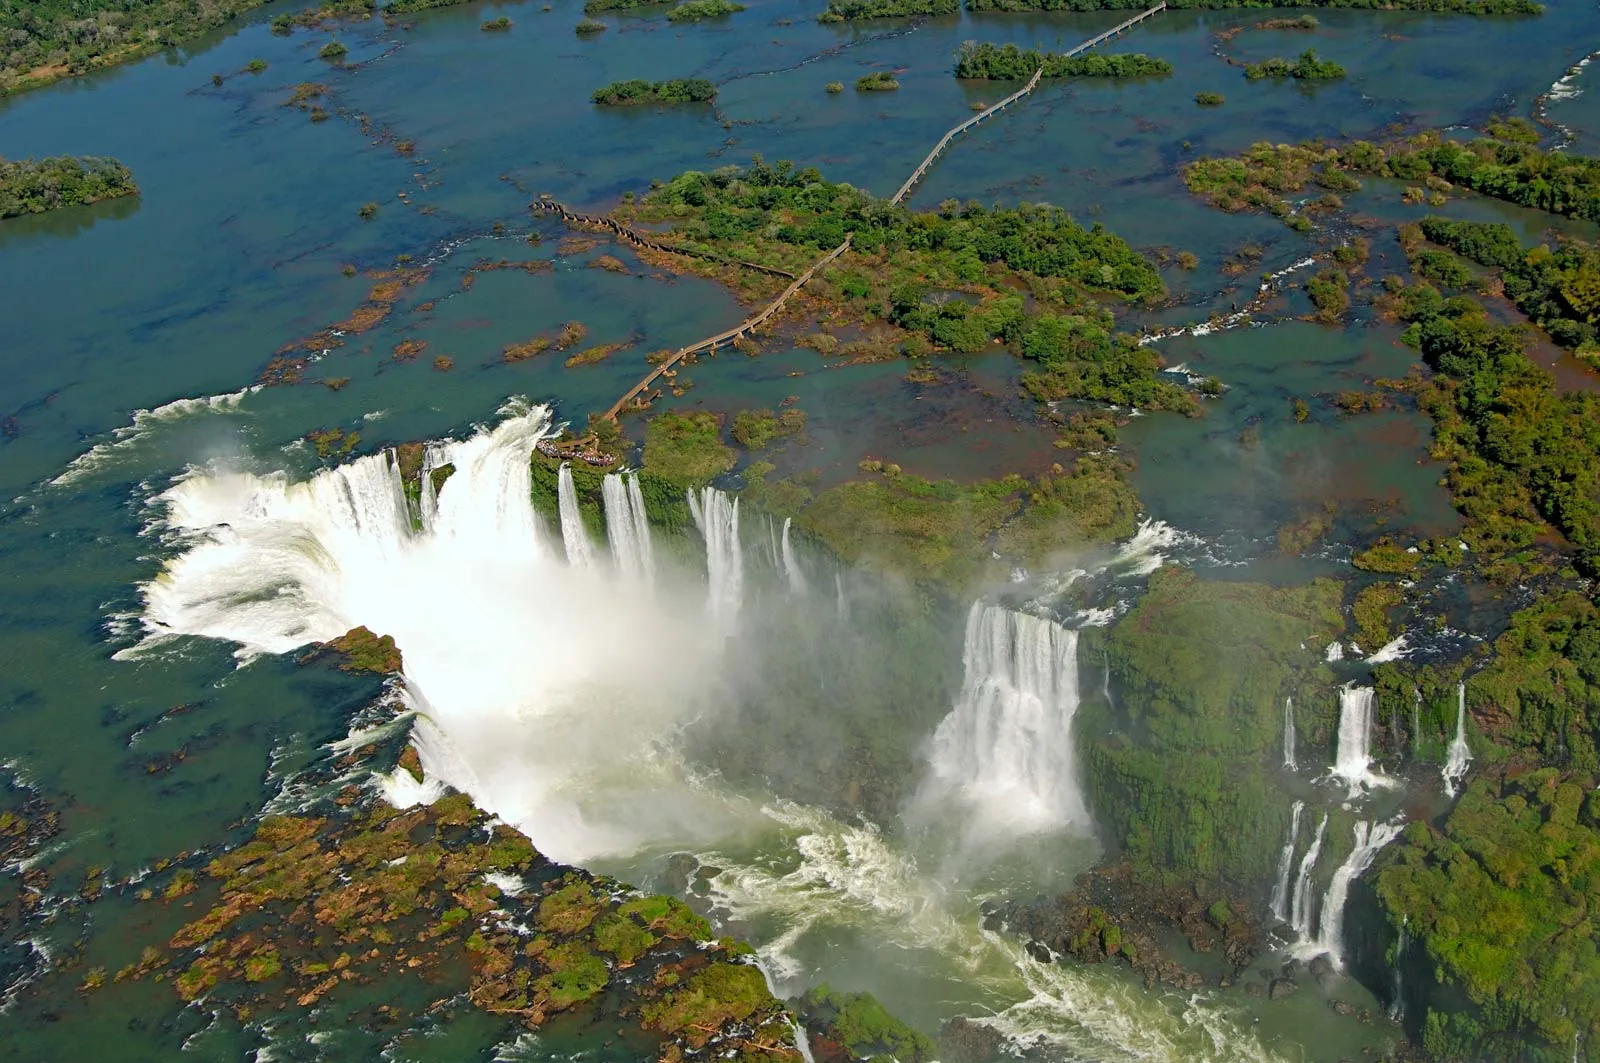What kind of vegetation thrives in this environment? Within the lush rainforest encircling the Iguazu Falls, a variety of vegetation flourishes. Towering trees form a dense canopy, sheltering numerous plant species that thrive in the humid and misty conditions. Ferns, orchids, and bromeliads find ideal habitats here, often clinging to tree trunks and branches. The understory is rich with shrubs and smaller plants adapted to low light. This diversity of plant life supports a complex ecosystem, providing food and shelter for countless animal species.  Let's imagine there's a hidden cave behind these falls. What secrets or treasures might it hold? Imagining a hidden cave behind the thundering curtain of the Iguazu Falls opens a door to a world of mystical wonders and ancient secrets. This cavern might house glittering mineral formations formed over millennia, their crystalline structures sparking in the dim light. Echoes of long-lost indigenous tribes might linger here, with ancient petroglyphs and artifacts buried in the depths, waiting to tell stories of a bygone era. Perhaps, among the rocks, rare and undiscovered plant species thrive in the unique microclimate, glowing softly in the cave's perpetual twilight. The air would hold a hint of long-forgotten tales of adventure and mystery, a place where legends and reality intertwine in the eternal dance of the waters. 